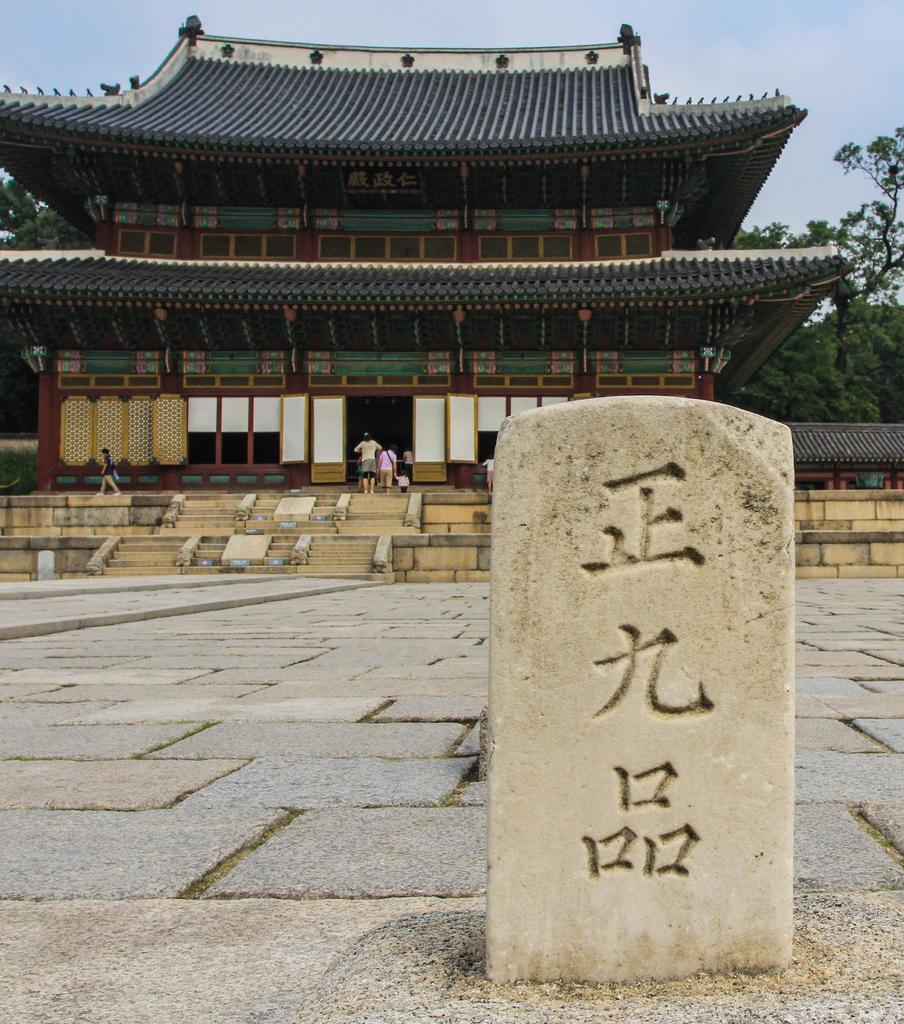In one or two sentences, can you explain what this image depicts? In this image in the background there is a building, and there are some people who are walking in to that building and also there are some stairs. In the foreground there is one pillar, and in the background there are some trees. On the top of the image there is sky. 